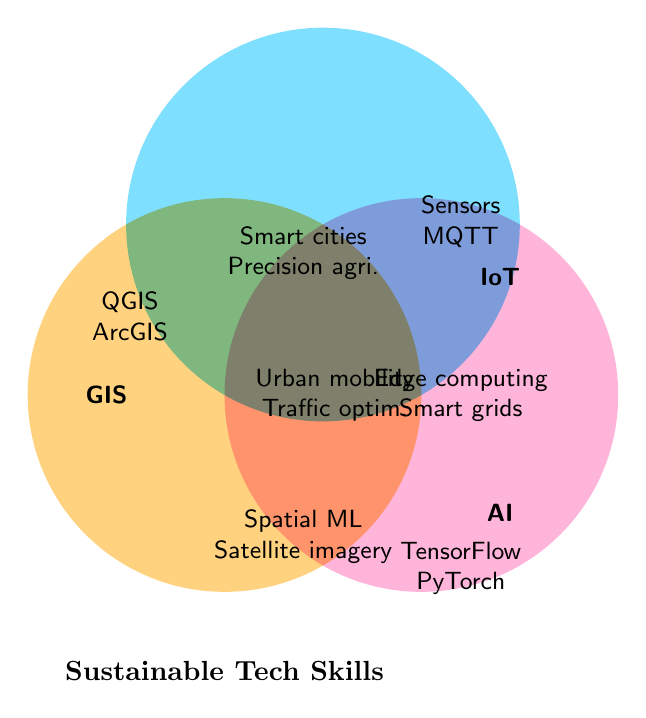What are the three main categories in the Venn Diagram? The labels at the edges of the circles indicate the main categories. They are 'GIS', 'IoT', and 'AI'.
Answer: GIS, IoT, AI How many elements are unique to GIS? The elements located within the GIS circle and not overlapping with IoT or AI are listed inside the GIS section. These are QGIS and ArcGIS.
Answer: 2 Which elements are shared between GIS and AI but not IoT? The elements in the overlapping section between GIS and AI but outside IoT are found in the segment labeled 'GIS_AI'. Those are Spatial ML and Satellite imagery analysis.
Answer: Spatial ML, Satellite imagery analysis What skill is common to all three categories? The element positioned in the center where all three circles overlap represents the skill common to all three categories. That is Urban mobility.
Answer: Urban mobility Which category has the skill 'Smart cities'? To find this, look for 'Smart cities' and see in which overlapping section it is located. 'Smart cities' is in the GIS_IoT section.
Answer: GIS and IoT Identify skills unique to IoT. The skills within the IoT circle but not overlapping with GIS or AI are located in the IoT section. These are Sensors and MQTT.
Answer: Sensors, MQTT How many skills are there in the IoT_AI intersection? The skills located in the intersection of the IoT and AI circles but not overlapping with GIS are listed. These are Edge computing and Smart grids.
Answer: 2 Which category or categories contain the skill 'Traffic optimization'? 'Traffic optimization' is in the intersection of GIS, IoT, and AI, as seen in the center of the Venn diagram.
Answer: GIS, IoT, AI Which skills are related to both GIS and IoT, but not AI? The elements in the overlap between GIS and IoT only are Smart cities and Precision agriculture.
Answer: Smart cities, Precision agriculture Are there more skills overlapping between GIS and AI or IoT and AI? First, count the skills in the GIS and AI intersection (Spatial ML, Satellite imagery analysis) and then count the skills in the IoT and AI intersection (Edge computing, Smart grids). Both intersections account for 2 skills.
Answer: Equal 